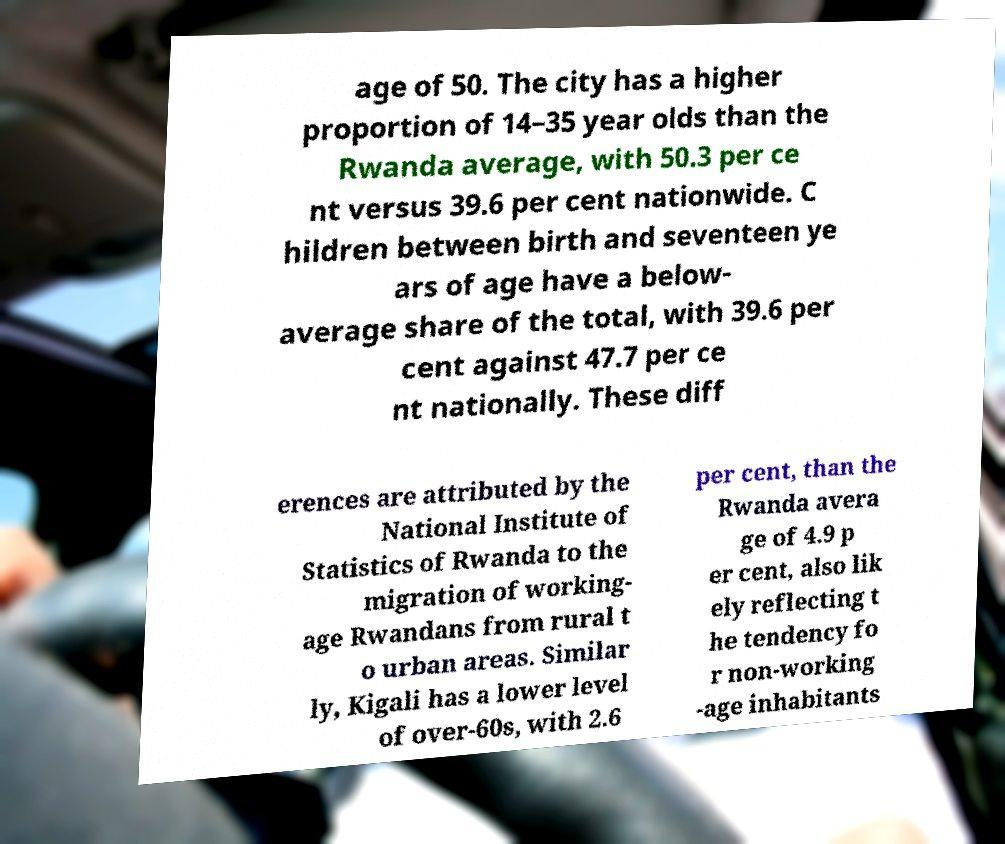Can you read and provide the text displayed in the image?This photo seems to have some interesting text. Can you extract and type it out for me? age of 50. The city has a higher proportion of 14–35 year olds than the Rwanda average, with 50.3 per ce nt versus 39.6 per cent nationwide. C hildren between birth and seventeen ye ars of age have a below- average share of the total, with 39.6 per cent against 47.7 per ce nt nationally. These diff erences are attributed by the National Institute of Statistics of Rwanda to the migration of working- age Rwandans from rural t o urban areas. Similar ly, Kigali has a lower level of over-60s, with 2.6 per cent, than the Rwanda avera ge of 4.9 p er cent, also lik ely reflecting t he tendency fo r non-working -age inhabitants 